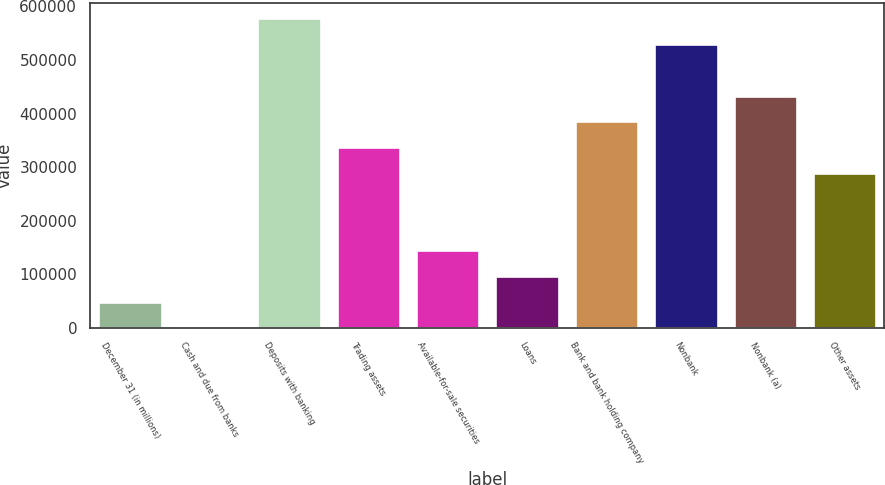Convert chart to OTSL. <chart><loc_0><loc_0><loc_500><loc_500><bar_chart><fcel>December 31 (in millions)<fcel>Cash and due from banks<fcel>Deposits with banking<fcel>Trading assets<fcel>Available-for-sale securities<fcel>Loans<fcel>Bank and bank holding company<fcel>Nonbank<fcel>Nonbank (a)<fcel>Other assets<nl><fcel>48333.8<fcel>211<fcel>577685<fcel>337071<fcel>144579<fcel>96456.6<fcel>385193<fcel>529562<fcel>433316<fcel>288948<nl></chart> 